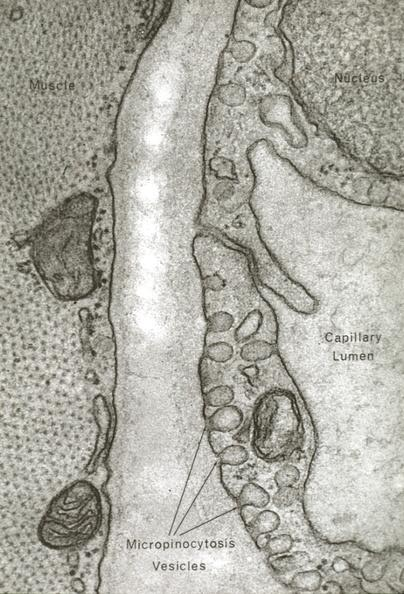s stillborn macerated present?
Answer the question using a single word or phrase. No 